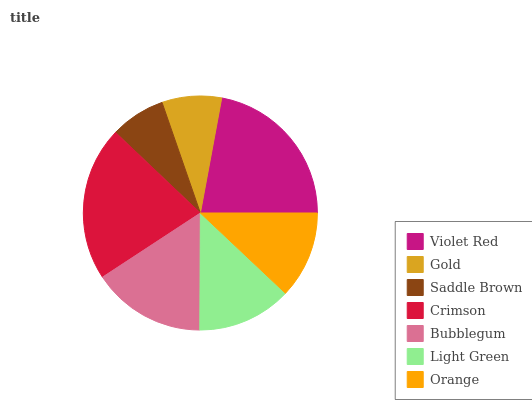Is Saddle Brown the minimum?
Answer yes or no. Yes. Is Violet Red the maximum?
Answer yes or no. Yes. Is Gold the minimum?
Answer yes or no. No. Is Gold the maximum?
Answer yes or no. No. Is Violet Red greater than Gold?
Answer yes or no. Yes. Is Gold less than Violet Red?
Answer yes or no. Yes. Is Gold greater than Violet Red?
Answer yes or no. No. Is Violet Red less than Gold?
Answer yes or no. No. Is Light Green the high median?
Answer yes or no. Yes. Is Light Green the low median?
Answer yes or no. Yes. Is Gold the high median?
Answer yes or no. No. Is Saddle Brown the low median?
Answer yes or no. No. 